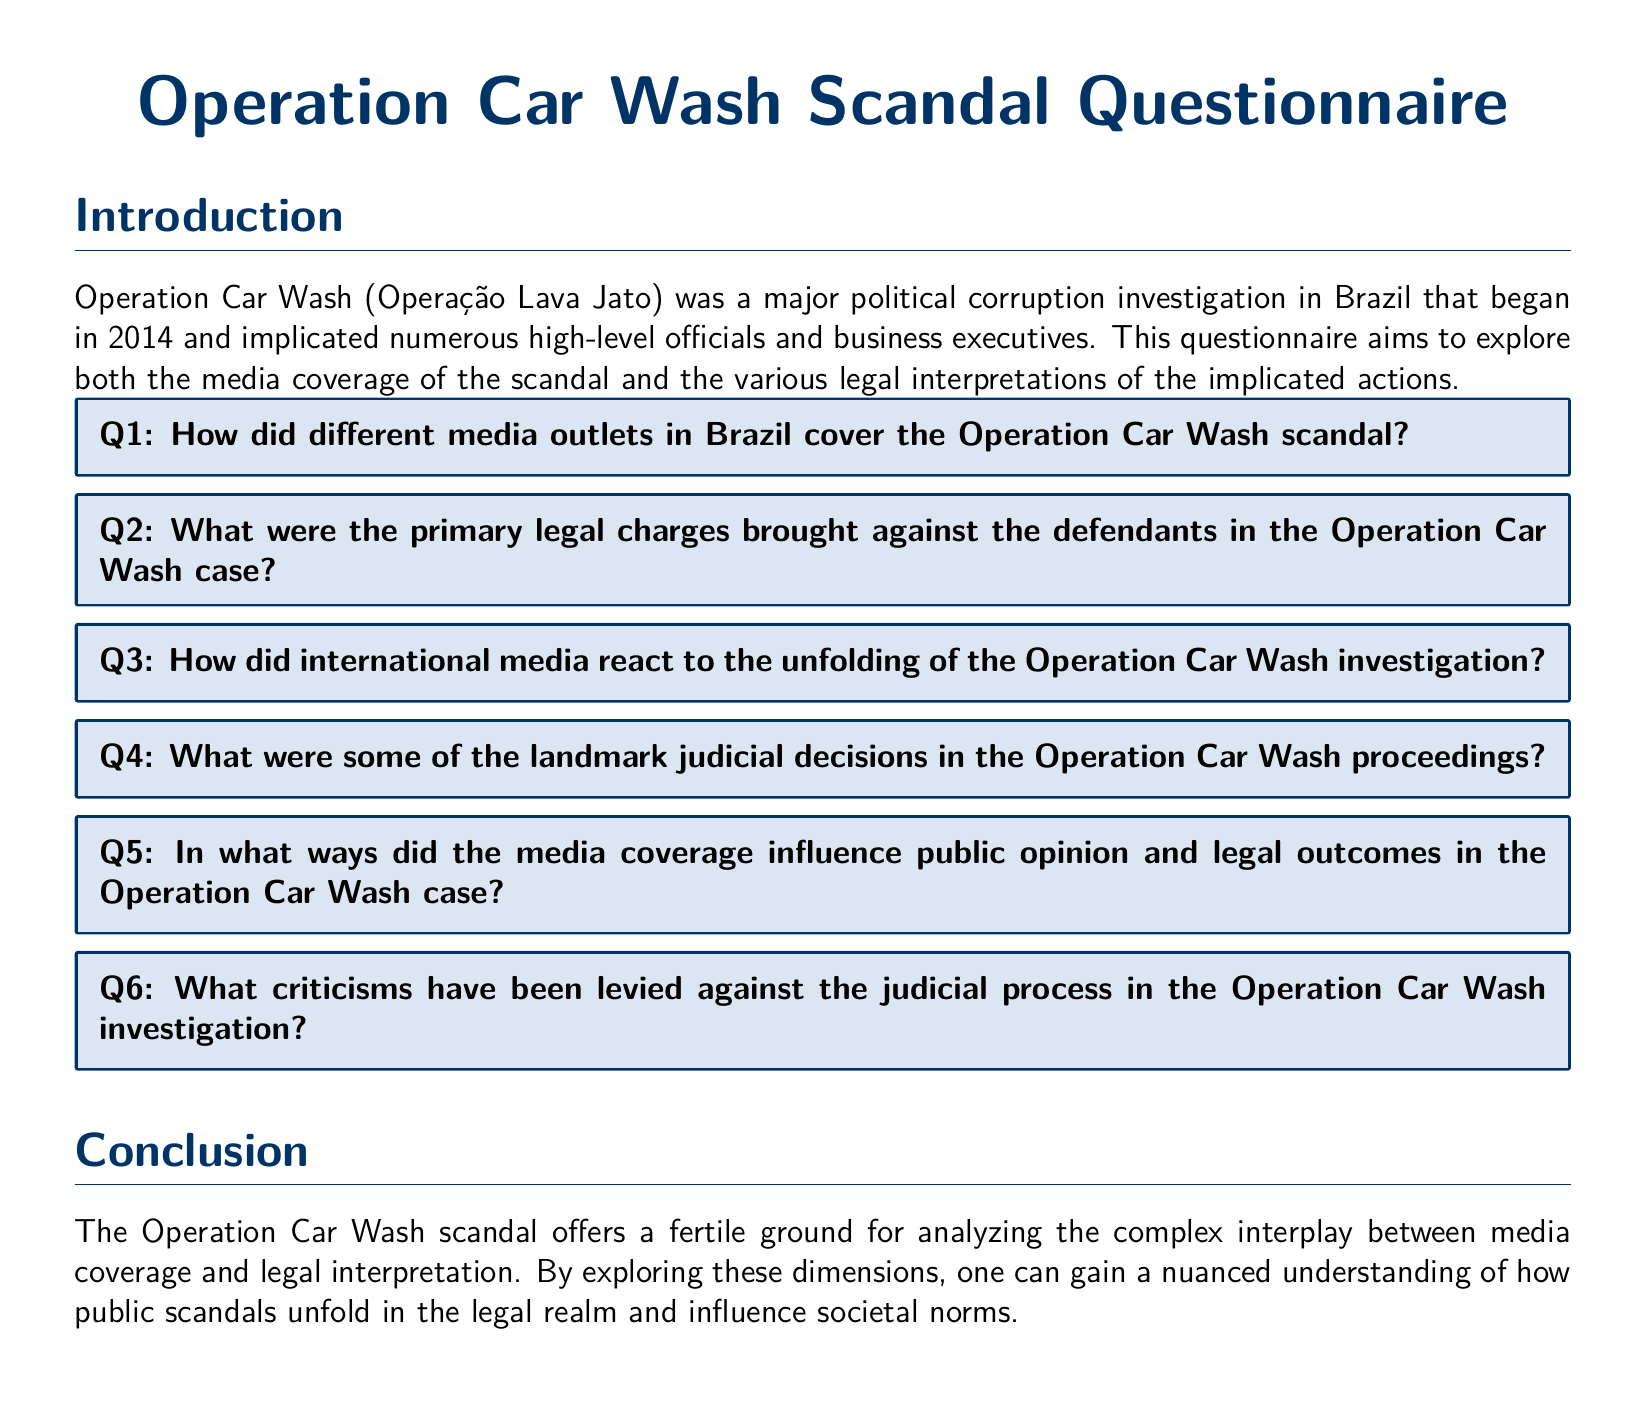What is the title of the questionnaire? The title provided in the document indicates the focus of the questionnaire, which is related to political corruption in Brazil.
Answer: Operation Car Wash Scandal Questionnaire How many primary legal charges are referenced in the document? The document hints at the presence of legal charges but does not specify a number; it encourages exploration of the topic.
Answer: Not specified What year did the Operation Car Wash investigation begin? The document explicitly mentions the year when the investigation commenced.
Answer: 2014 What theme is discussed in the conclusion of the document? The conclusion highlights the relationship between media coverage and legal interpretation as the main theme.
Answer: Media coverage and legal interpretation What is the first question posed in the questionnaire? The first question listed addresses the media coverage aspect of the scandal.
Answer: How did different media outlets in Brazil cover the Operation Car Wash scandal? 